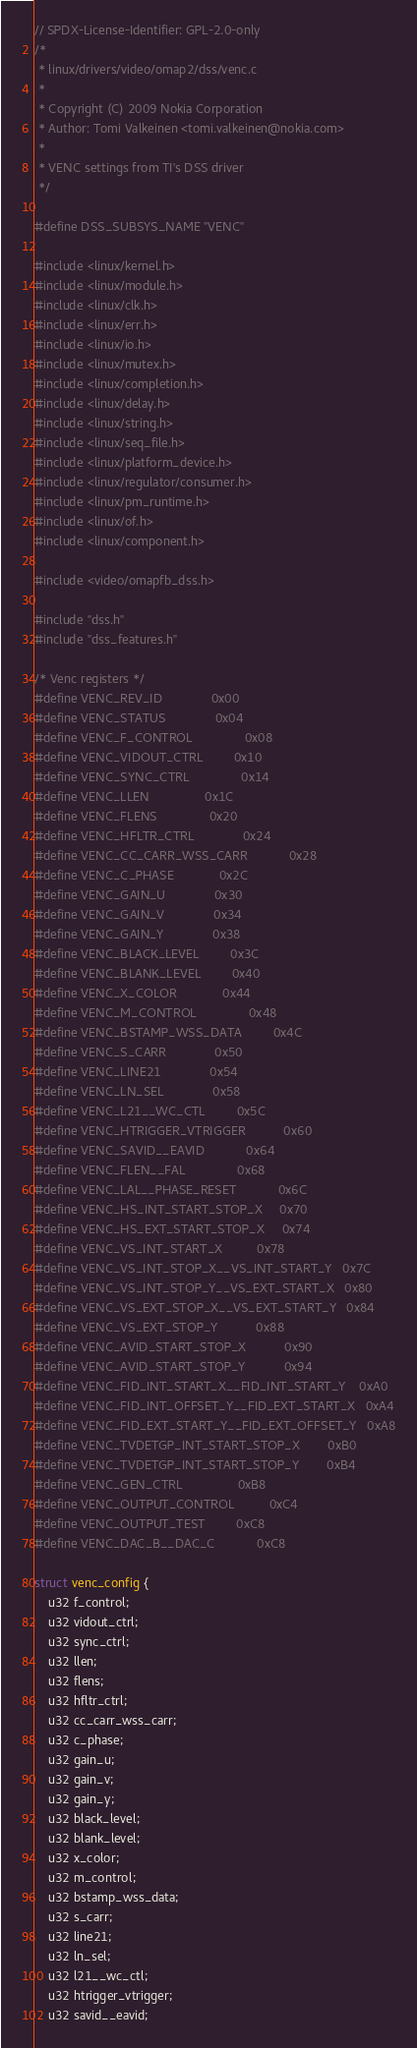Convert code to text. <code><loc_0><loc_0><loc_500><loc_500><_C_>// SPDX-License-Identifier: GPL-2.0-only
/*
 * linux/drivers/video/omap2/dss/venc.c
 *
 * Copyright (C) 2009 Nokia Corporation
 * Author: Tomi Valkeinen <tomi.valkeinen@nokia.com>
 *
 * VENC settings from TI's DSS driver
 */

#define DSS_SUBSYS_NAME "VENC"

#include <linux/kernel.h>
#include <linux/module.h>
#include <linux/clk.h>
#include <linux/err.h>
#include <linux/io.h>
#include <linux/mutex.h>
#include <linux/completion.h>
#include <linux/delay.h>
#include <linux/string.h>
#include <linux/seq_file.h>
#include <linux/platform_device.h>
#include <linux/regulator/consumer.h>
#include <linux/pm_runtime.h>
#include <linux/of.h>
#include <linux/component.h>

#include <video/omapfb_dss.h>

#include "dss.h"
#include "dss_features.h"

/* Venc registers */
#define VENC_REV_ID				0x00
#define VENC_STATUS				0x04
#define VENC_F_CONTROL				0x08
#define VENC_VIDOUT_CTRL			0x10
#define VENC_SYNC_CTRL				0x14
#define VENC_LLEN				0x1C
#define VENC_FLENS				0x20
#define VENC_HFLTR_CTRL				0x24
#define VENC_CC_CARR_WSS_CARR			0x28
#define VENC_C_PHASE				0x2C
#define VENC_GAIN_U				0x30
#define VENC_GAIN_V				0x34
#define VENC_GAIN_Y				0x38
#define VENC_BLACK_LEVEL			0x3C
#define VENC_BLANK_LEVEL			0x40
#define VENC_X_COLOR				0x44
#define VENC_M_CONTROL				0x48
#define VENC_BSTAMP_WSS_DATA			0x4C
#define VENC_S_CARR				0x50
#define VENC_LINE21				0x54
#define VENC_LN_SEL				0x58
#define VENC_L21__WC_CTL			0x5C
#define VENC_HTRIGGER_VTRIGGER			0x60
#define VENC_SAVID__EAVID			0x64
#define VENC_FLEN__FAL				0x68
#define VENC_LAL__PHASE_RESET			0x6C
#define VENC_HS_INT_START_STOP_X		0x70
#define VENC_HS_EXT_START_STOP_X		0x74
#define VENC_VS_INT_START_X			0x78
#define VENC_VS_INT_STOP_X__VS_INT_START_Y	0x7C
#define VENC_VS_INT_STOP_Y__VS_EXT_START_X	0x80
#define VENC_VS_EXT_STOP_X__VS_EXT_START_Y	0x84
#define VENC_VS_EXT_STOP_Y			0x88
#define VENC_AVID_START_STOP_X			0x90
#define VENC_AVID_START_STOP_Y			0x94
#define VENC_FID_INT_START_X__FID_INT_START_Y	0xA0
#define VENC_FID_INT_OFFSET_Y__FID_EXT_START_X	0xA4
#define VENC_FID_EXT_START_Y__FID_EXT_OFFSET_Y	0xA8
#define VENC_TVDETGP_INT_START_STOP_X		0xB0
#define VENC_TVDETGP_INT_START_STOP_Y		0xB4
#define VENC_GEN_CTRL				0xB8
#define VENC_OUTPUT_CONTROL			0xC4
#define VENC_OUTPUT_TEST			0xC8
#define VENC_DAC_B__DAC_C			0xC8

struct venc_config {
	u32 f_control;
	u32 vidout_ctrl;
	u32 sync_ctrl;
	u32 llen;
	u32 flens;
	u32 hfltr_ctrl;
	u32 cc_carr_wss_carr;
	u32 c_phase;
	u32 gain_u;
	u32 gain_v;
	u32 gain_y;
	u32 black_level;
	u32 blank_level;
	u32 x_color;
	u32 m_control;
	u32 bstamp_wss_data;
	u32 s_carr;
	u32 line21;
	u32 ln_sel;
	u32 l21__wc_ctl;
	u32 htrigger_vtrigger;
	u32 savid__eavid;</code> 